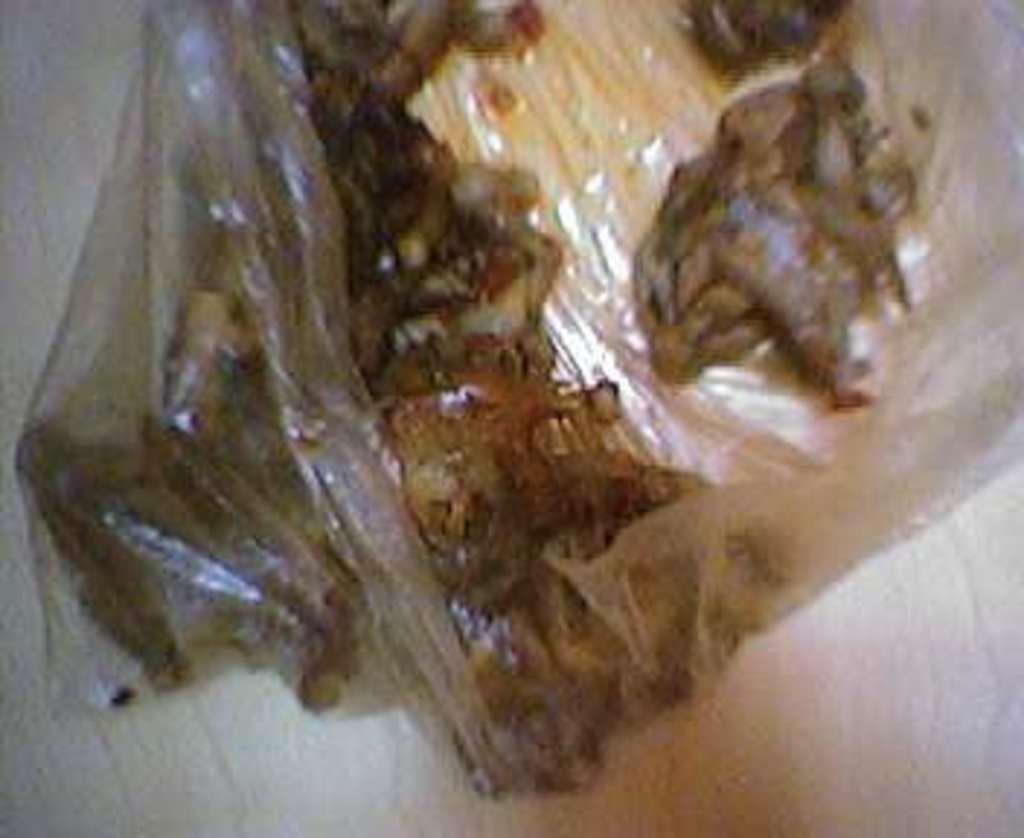What is present in the image? There is a cover in the image. How many jellyfish can be seen swimming under the cover in the image? There are no jellyfish present in the image; it only features a cover. What scientific theory is being discussed in the image? There is no discussion of a scientific theory in the image, as it only features a cover. 